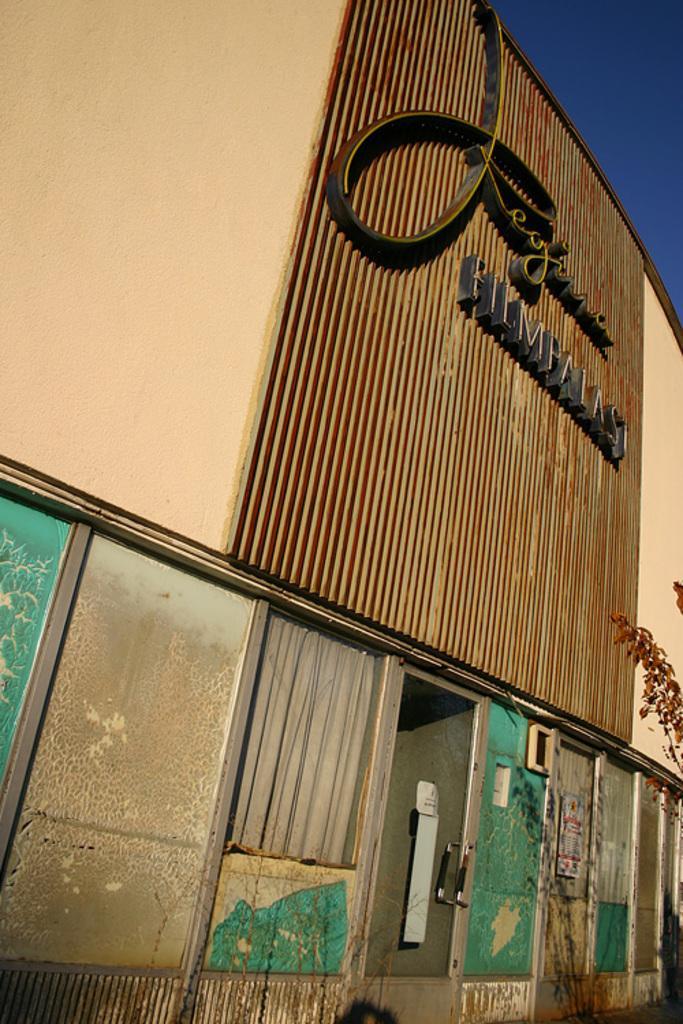Please provide a concise description of this image. In this image we can see a building with a name. Also there are windows. On the right side we can see branch of a tree. In the right top corner there is sky. 